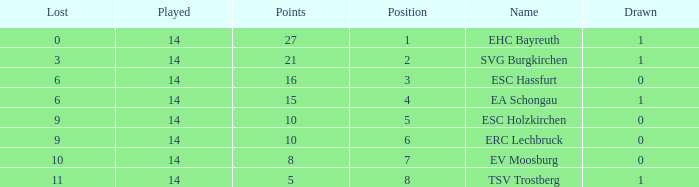What's the lost when there were more than 16 points and had a drawn less than 1? None. 